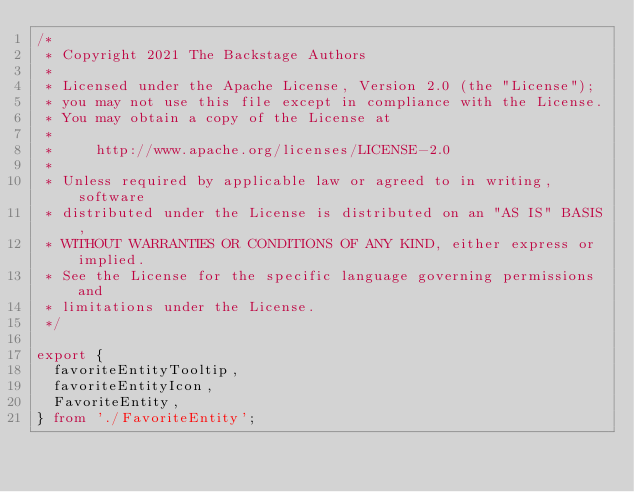Convert code to text. <code><loc_0><loc_0><loc_500><loc_500><_TypeScript_>/*
 * Copyright 2021 The Backstage Authors
 *
 * Licensed under the Apache License, Version 2.0 (the "License");
 * you may not use this file except in compliance with the License.
 * You may obtain a copy of the License at
 *
 *     http://www.apache.org/licenses/LICENSE-2.0
 *
 * Unless required by applicable law or agreed to in writing, software
 * distributed under the License is distributed on an "AS IS" BASIS,
 * WITHOUT WARRANTIES OR CONDITIONS OF ANY KIND, either express or implied.
 * See the License for the specific language governing permissions and
 * limitations under the License.
 */

export {
  favoriteEntityTooltip,
  favoriteEntityIcon,
  FavoriteEntity,
} from './FavoriteEntity';
</code> 